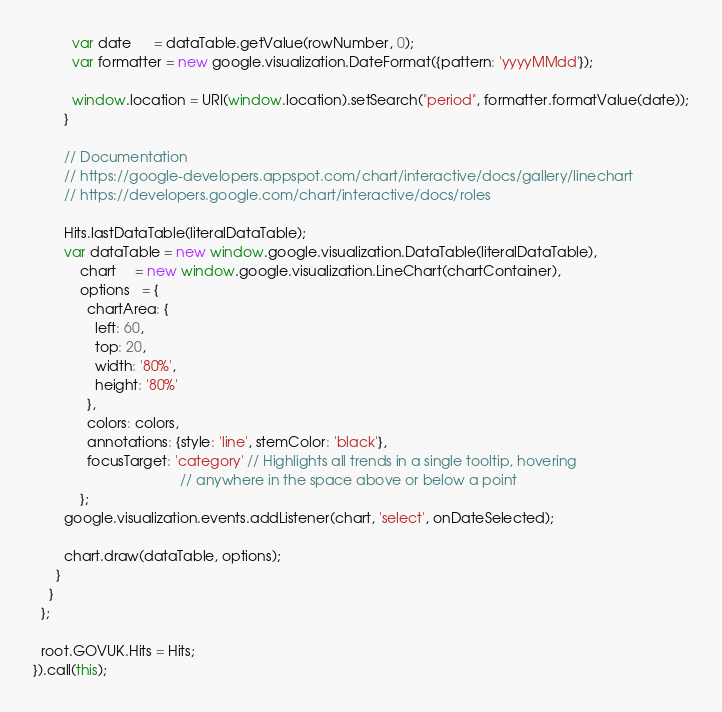<code> <loc_0><loc_0><loc_500><loc_500><_JavaScript_>          var date      = dataTable.getValue(rowNumber, 0);
          var formatter = new google.visualization.DateFormat({pattern: 'yyyyMMdd'});

          window.location = URI(window.location).setSearch("period", formatter.formatValue(date));
        }

        // Documentation
        // https://google-developers.appspot.com/chart/interactive/docs/gallery/linechart
        // https://developers.google.com/chart/interactive/docs/roles

        Hits.lastDataTable(literalDataTable);
        var dataTable = new window.google.visualization.DataTable(literalDataTable),
            chart     = new window.google.visualization.LineChart(chartContainer),
            options   = {
              chartArea: {
                left: 60,
                top: 20,
                width: '80%',
                height: '80%'
              },
              colors: colors,
              annotations: {style: 'line', stemColor: 'black'},
              focusTarget: 'category' // Highlights all trends in a single tooltip, hovering
                                      // anywhere in the space above or below a point
            };
        google.visualization.events.addListener(chart, 'select', onDateSelected);

        chart.draw(dataTable, options);
      }
    }
  };

  root.GOVUK.Hits = Hits;
}).call(this);
</code> 